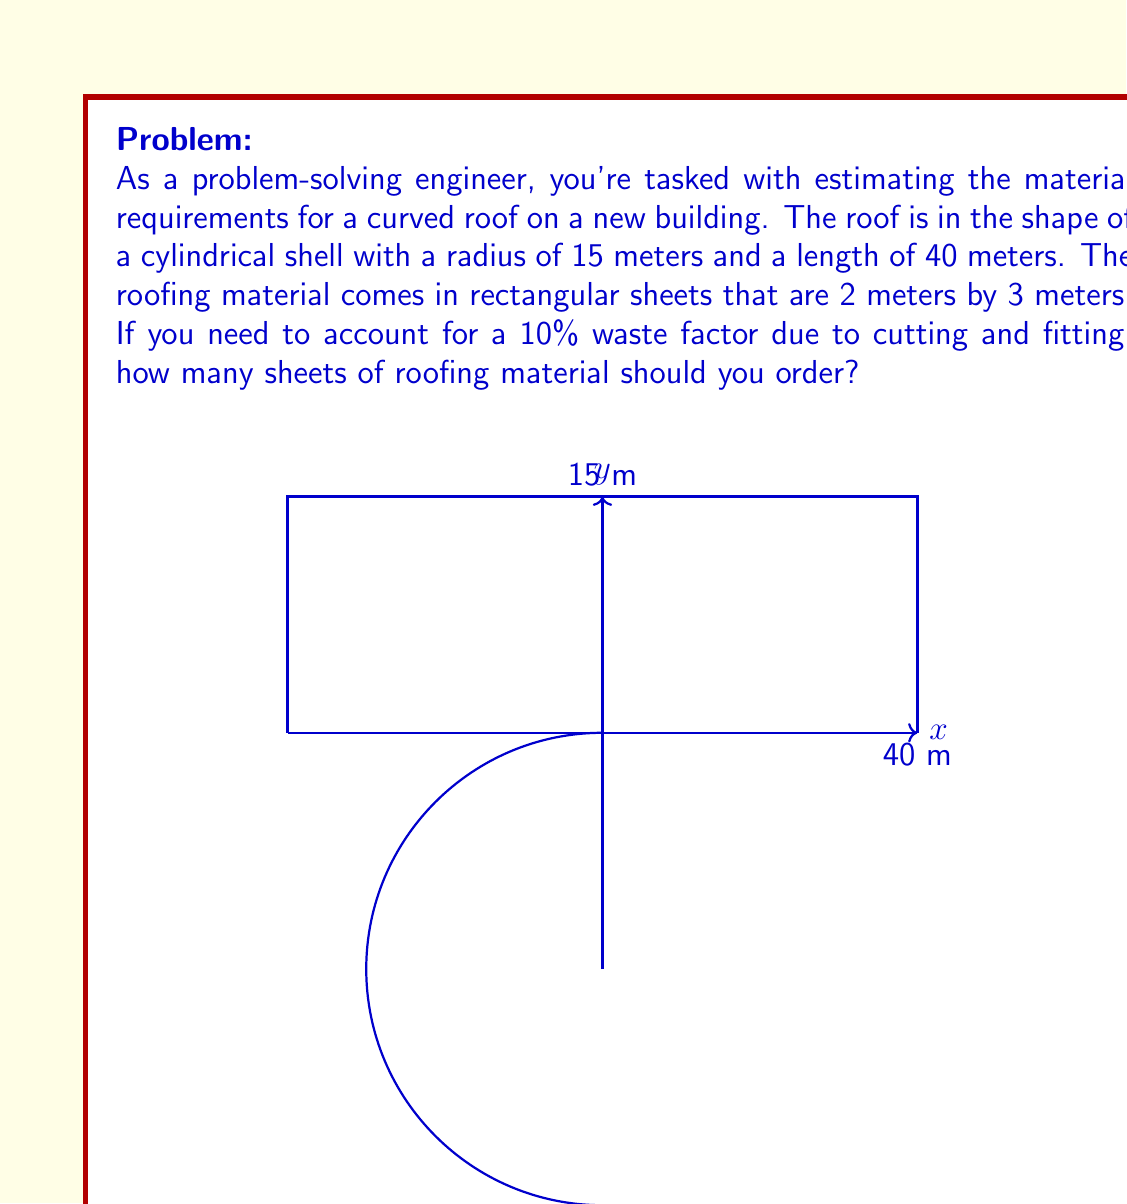Show me your answer to this math problem. Let's approach this problem step by step:

1) First, we need to calculate the surface area of the cylindrical roof. The formula for the surface area of a cylinder (excluding the ends) is:

   $$A = 2\pi r l$$

   Where $r$ is the radius and $l$ is the length.

2) Plugging in our values:

   $$A = 2\pi \cdot 15 \text{ m} \cdot 40 \text{ m} = 3769.91 \text{ m}^2$$

3) Now, we need to account for the 10% waste factor. We can do this by multiplying our area by 1.1:

   $$A_{\text{with waste}} = 3769.91 \text{ m}^2 \cdot 1.1 = 4146.90 \text{ m}^2$$

4) Each sheet of roofing material covers:

   $$2 \text{ m} \cdot 3 \text{ m} = 6 \text{ m}^2$$

5) To find the number of sheets needed, we divide the total area (including waste) by the area of each sheet:

   $$\text{Number of sheets} = \frac{4146.90 \text{ m}^2}{6 \text{ m}^2} = 691.15$$

6) Since we can't order a fractional number of sheets, we need to round up to the nearest whole number.
Answer: 692 sheets of roofing material should be ordered. 